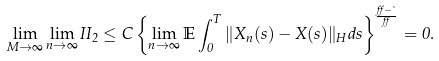<formula> <loc_0><loc_0><loc_500><loc_500>\lim _ { M \rightarrow \infty } \lim _ { n \rightarrow \infty } I I _ { 2 } \leq C \left \{ \lim _ { n \rightarrow \infty } \mathbb { E } \int _ { 0 } ^ { T } \| X _ { n } ( s ) - X ( s ) \| _ { H } d s \right \} ^ { \frac { \alpha - \theta } { \alpha } } = 0 .</formula> 